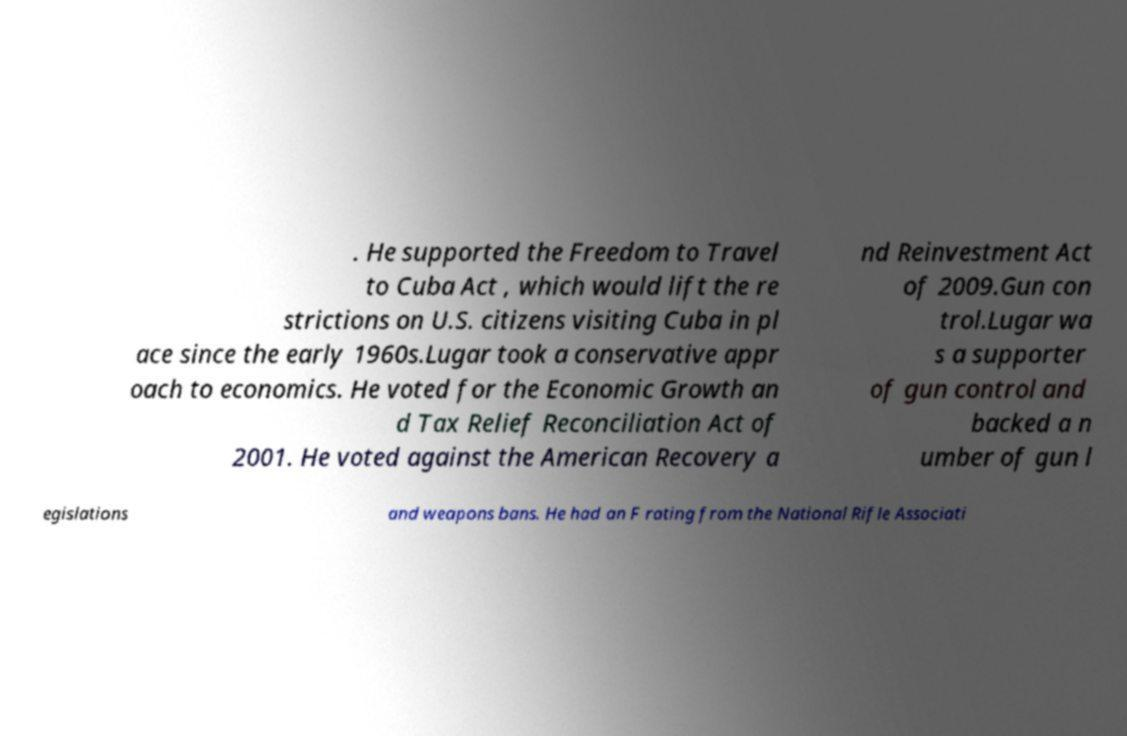For documentation purposes, I need the text within this image transcribed. Could you provide that? . He supported the Freedom to Travel to Cuba Act , which would lift the re strictions on U.S. citizens visiting Cuba in pl ace since the early 1960s.Lugar took a conservative appr oach to economics. He voted for the Economic Growth an d Tax Relief Reconciliation Act of 2001. He voted against the American Recovery a nd Reinvestment Act of 2009.Gun con trol.Lugar wa s a supporter of gun control and backed a n umber of gun l egislations and weapons bans. He had an F rating from the National Rifle Associati 